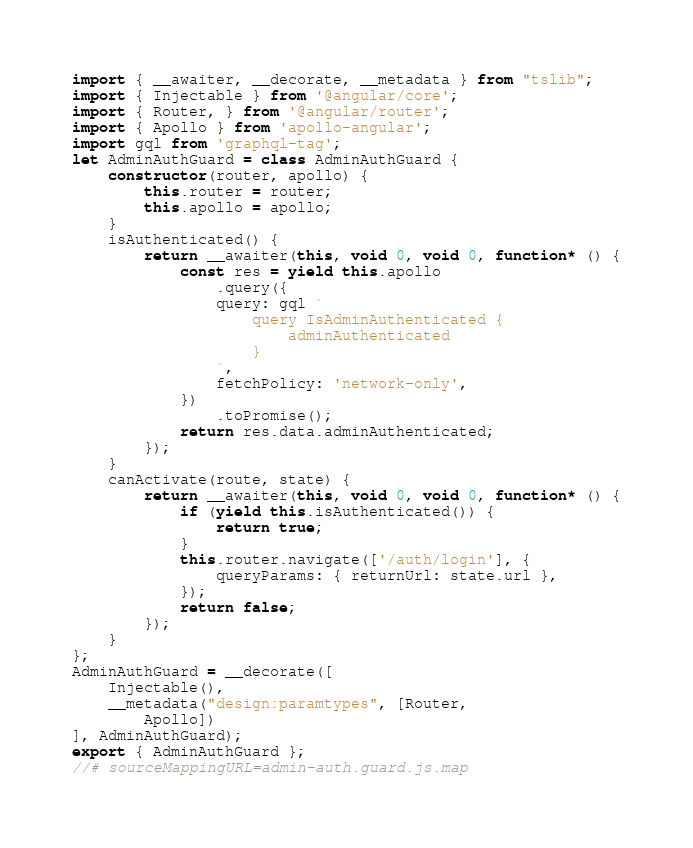Convert code to text. <code><loc_0><loc_0><loc_500><loc_500><_JavaScript_>import { __awaiter, __decorate, __metadata } from "tslib";
import { Injectable } from '@angular/core';
import { Router, } from '@angular/router';
import { Apollo } from 'apollo-angular';
import gql from 'graphql-tag';
let AdminAuthGuard = class AdminAuthGuard {
    constructor(router, apollo) {
        this.router = router;
        this.apollo = apollo;
    }
    isAuthenticated() {
        return __awaiter(this, void 0, void 0, function* () {
            const res = yield this.apollo
                .query({
                query: gql `
					query IsAdminAuthenticated {
						adminAuthenticated
					}
				`,
                fetchPolicy: 'network-only',
            })
                .toPromise();
            return res.data.adminAuthenticated;
        });
    }
    canActivate(route, state) {
        return __awaiter(this, void 0, void 0, function* () {
            if (yield this.isAuthenticated()) {
                return true;
            }
            this.router.navigate(['/auth/login'], {
                queryParams: { returnUrl: state.url },
            });
            return false;
        });
    }
};
AdminAuthGuard = __decorate([
    Injectable(),
    __metadata("design:paramtypes", [Router,
        Apollo])
], AdminAuthGuard);
export { AdminAuthGuard };
//# sourceMappingURL=admin-auth.guard.js.map</code> 